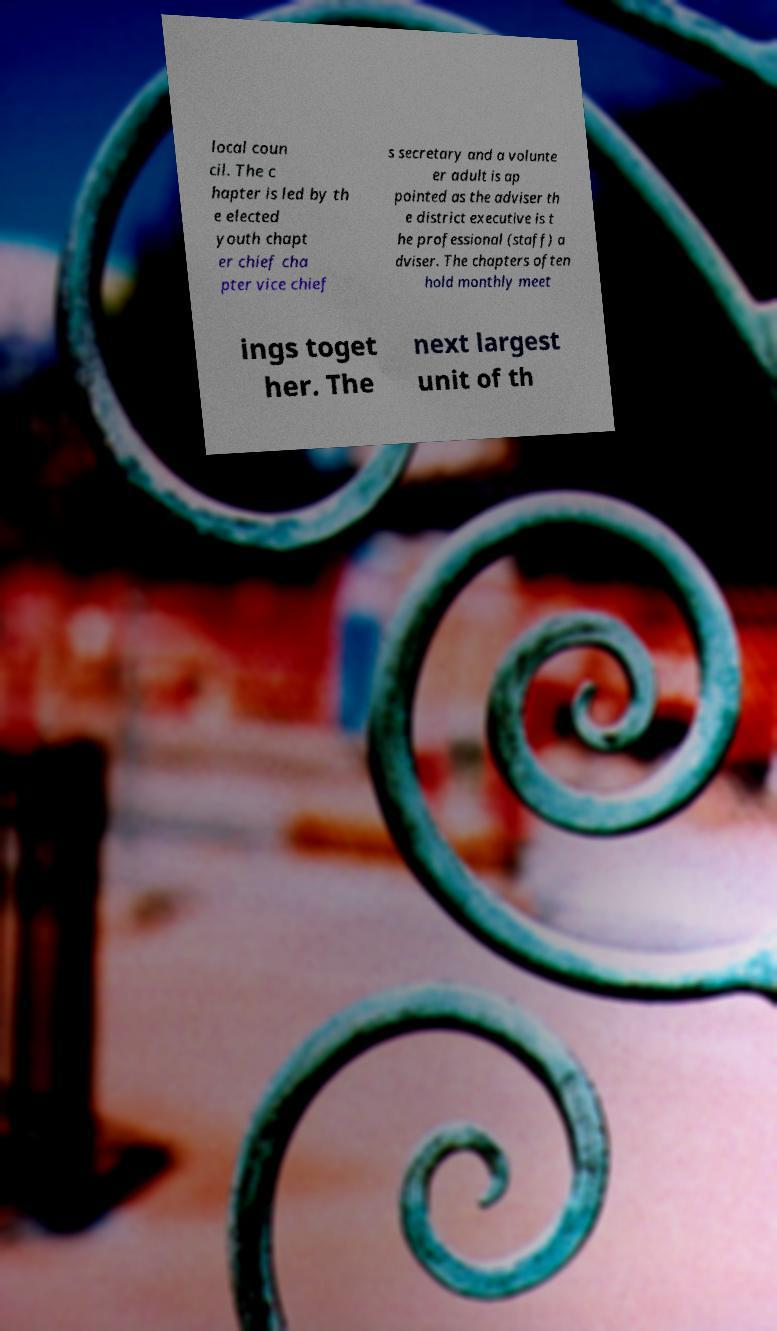There's text embedded in this image that I need extracted. Can you transcribe it verbatim? local coun cil. The c hapter is led by th e elected youth chapt er chief cha pter vice chief s secretary and a volunte er adult is ap pointed as the adviser th e district executive is t he professional (staff) a dviser. The chapters often hold monthly meet ings toget her. The next largest unit of th 